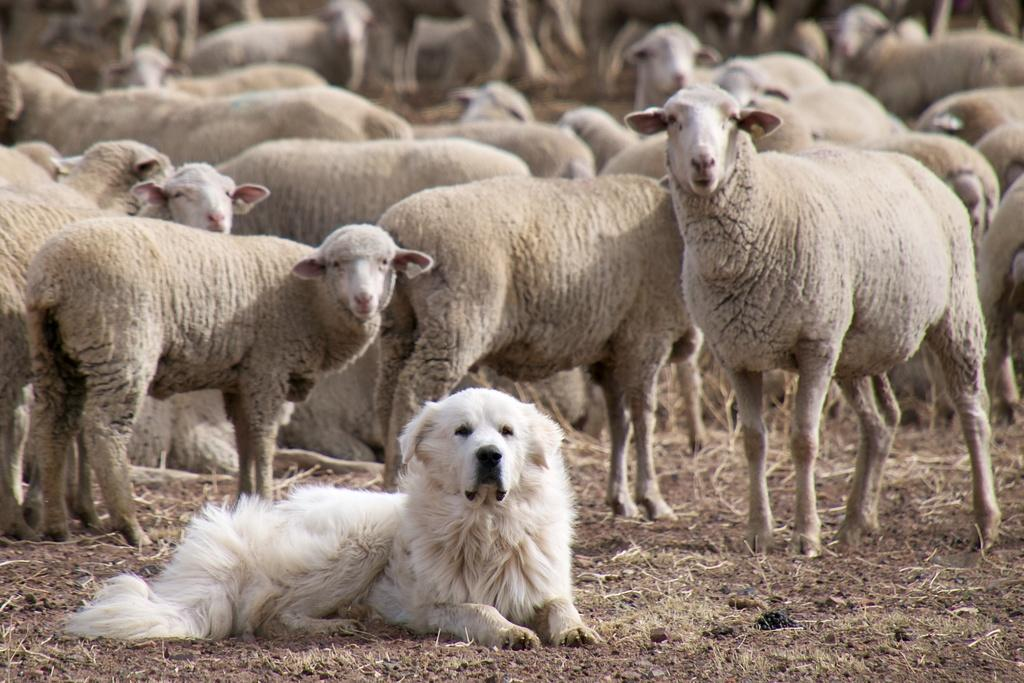What type of animal can be seen in the image? There is a dog in the image. What other animals are present in the image? There are sheep on the ground in the image. What type of vegetation is visible in the image? Dried grass is visible in the image. What type of bread is being used to start a fire in the image? There is no bread or fire present in the image; it features a dog and sheep in a grassy area. 